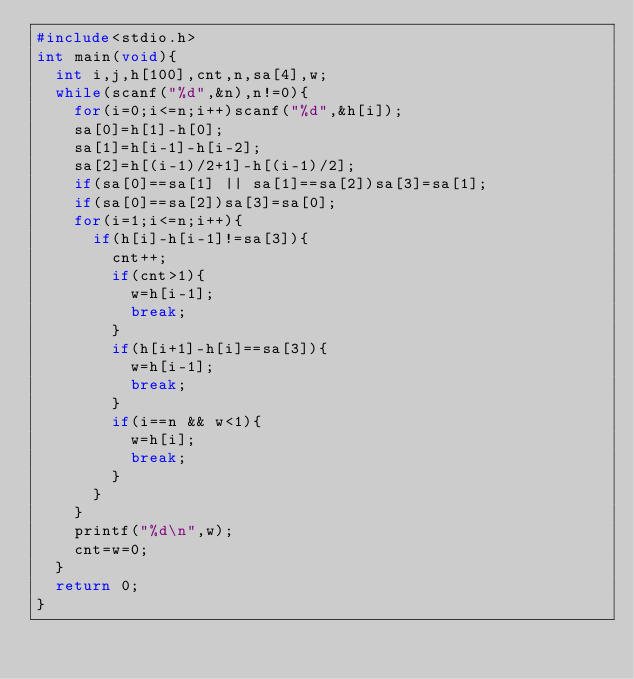<code> <loc_0><loc_0><loc_500><loc_500><_C_>#include<stdio.h>
int main(void){
	int i,j,h[100],cnt,n,sa[4],w;
	while(scanf("%d",&n),n!=0){
		for(i=0;i<=n;i++)scanf("%d",&h[i]);
		sa[0]=h[1]-h[0];
		sa[1]=h[i-1]-h[i-2];
		sa[2]=h[(i-1)/2+1]-h[(i-1)/2];
		if(sa[0]==sa[1] || sa[1]==sa[2])sa[3]=sa[1];
		if(sa[0]==sa[2])sa[3]=sa[0];
		for(i=1;i<=n;i++){
			if(h[i]-h[i-1]!=sa[3]){
				cnt++;
				if(cnt>1){
					w=h[i-1];
					break;
				}
				if(h[i+1]-h[i]==sa[3]){
					w=h[i-1];
					break;
				}
				if(i==n && w<1){
					w=h[i];
					break;
				}
			}
		}
		printf("%d\n",w);
		cnt=w=0;
	}
	return 0;
}</code> 